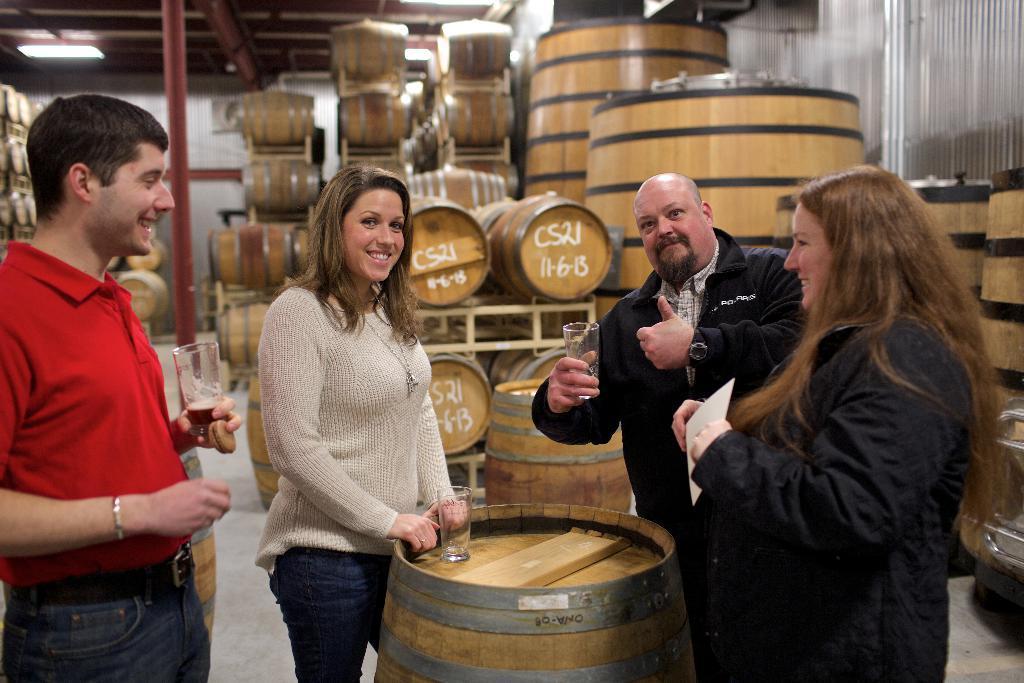Can you describe this image briefly? In this image I can see 4 people standing. They are holding a glasses and a person on the right is holding a paper. There are many barrels and a pole at the back. There is a light at the top. 